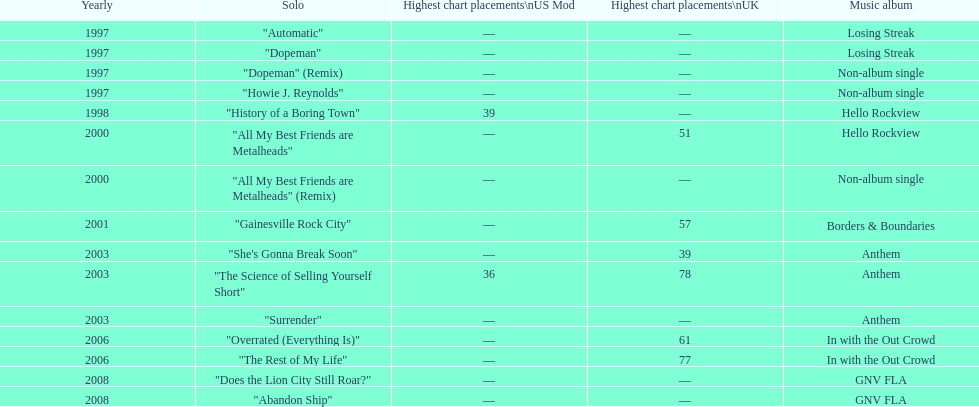Can you parse all the data within this table? {'header': ['Yearly', 'Solo', 'Highest chart placements\\nUS Mod', 'Highest chart placements\\nUK', 'Music album'], 'rows': [['1997', '"Automatic"', '—', '—', 'Losing Streak'], ['1997', '"Dopeman"', '—', '—', 'Losing Streak'], ['1997', '"Dopeman" (Remix)', '—', '—', 'Non-album single'], ['1997', '"Howie J. Reynolds"', '—', '—', 'Non-album single'], ['1998', '"History of a Boring Town"', '39', '—', 'Hello Rockview'], ['2000', '"All My Best Friends are Metalheads"', '—', '51', 'Hello Rockview'], ['2000', '"All My Best Friends are Metalheads" (Remix)', '—', '—', 'Non-album single'], ['2001', '"Gainesville Rock City"', '—', '57', 'Borders & Boundaries'], ['2003', '"She\'s Gonna Break Soon"', '—', '39', 'Anthem'], ['2003', '"The Science of Selling Yourself Short"', '36', '78', 'Anthem'], ['2003', '"Surrender"', '—', '—', 'Anthem'], ['2006', '"Overrated (Everything Is)"', '—', '61', 'In with the Out Crowd'], ['2006', '"The Rest of My Life"', '—', '77', 'In with the Out Crowd'], ['2008', '"Does the Lion City Still Roar?"', '—', '—', 'GNV FLA'], ['2008', '"Abandon Ship"', '—', '—', 'GNV FLA']]} Which song came out first? dopeman or surrender. Dopeman. 